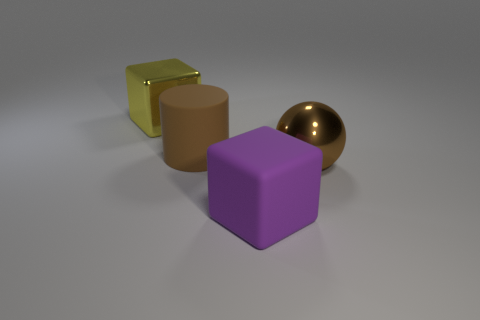How big is the block right of the cube left of the large rubber cylinder?
Offer a terse response. Large. How many things are cubes in front of the large yellow thing or big metal things that are left of the large brown shiny thing?
Offer a very short reply. 2. Are there fewer big matte cylinders than big red balls?
Your response must be concise. No. What number of objects are either purple metal cubes or big purple rubber objects?
Offer a terse response. 1. Is the brown metallic thing the same shape as the big yellow metal thing?
Your answer should be very brief. No. Are there any other things that are the same material as the large purple object?
Make the answer very short. Yes. There is a thing left of the large matte cylinder; does it have the same size as the cube in front of the big matte cylinder?
Provide a succinct answer. Yes. There is a object that is both right of the brown rubber object and behind the purple thing; what is it made of?
Provide a short and direct response. Metal. Is there any other thing that has the same color as the sphere?
Keep it short and to the point. Yes. Is the number of large brown metallic spheres behind the large purple thing less than the number of large red shiny cubes?
Provide a succinct answer. No. 